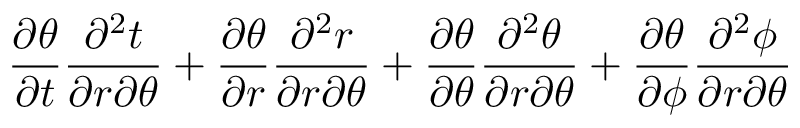<formula> <loc_0><loc_0><loc_500><loc_500>\frac { \partial \theta } { \partial t } \frac { \partial ^ { 2 } t } { \partial r \partial \theta } + \frac { \partial \theta } { \partial r } \frac { \partial ^ { 2 } r } { \partial r \partial \theta } + \frac { \partial \theta } { \partial \theta } \frac { \partial ^ { 2 } \theta } { \partial r \partial \theta } + \frac { \partial \theta } { \partial \phi } \frac { \partial ^ { 2 } \phi } { \partial r \partial \theta }</formula> 